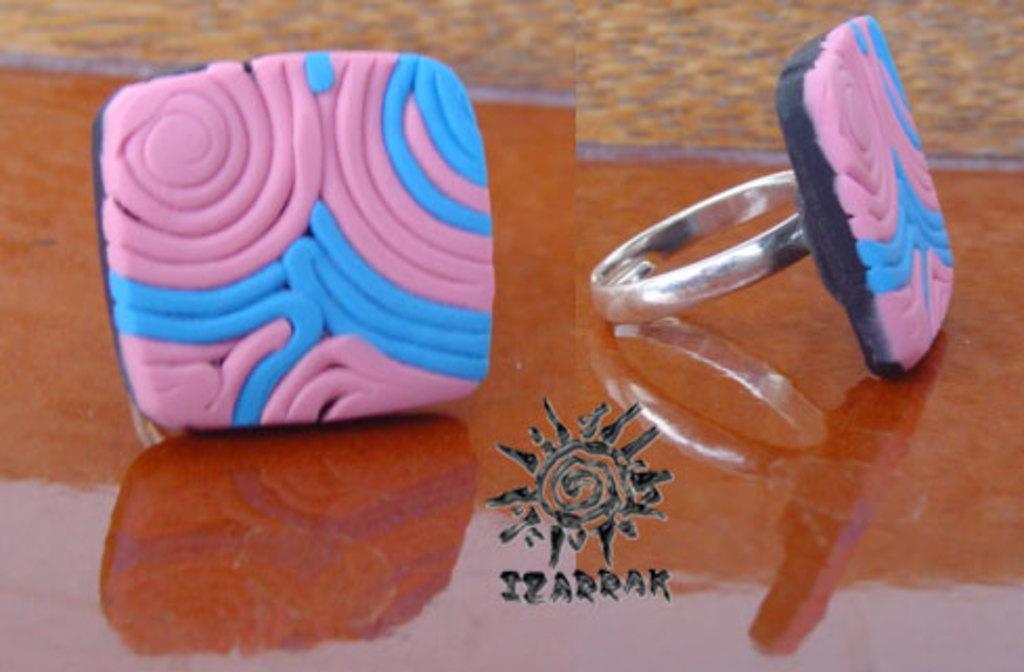Could you give a brief overview of what you see in this image? In the picture we can see a table on it we can see two finger rings with pink and white color lines on it. 